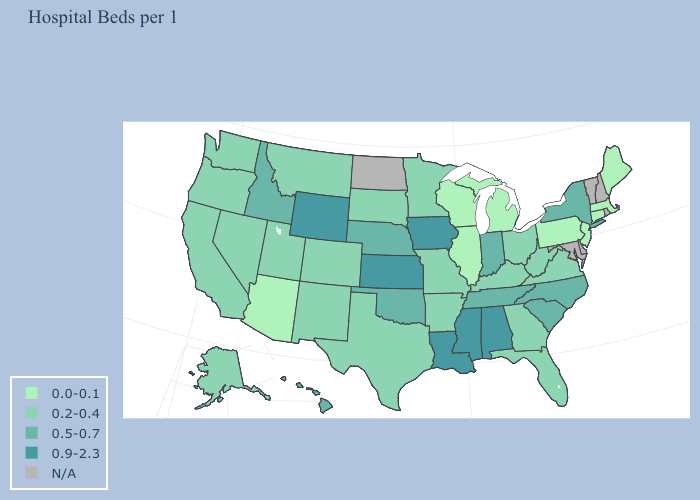How many symbols are there in the legend?
Keep it brief. 5. What is the value of Arkansas?
Short answer required. 0.2-0.4. What is the value of Minnesota?
Quick response, please. 0.2-0.4. What is the value of California?
Quick response, please. 0.2-0.4. What is the highest value in states that border New Hampshire?
Answer briefly. 0.0-0.1. What is the lowest value in the Northeast?
Short answer required. 0.0-0.1. Which states have the lowest value in the West?
Quick response, please. Arizona. Is the legend a continuous bar?
Give a very brief answer. No. Is the legend a continuous bar?
Answer briefly. No. What is the value of Idaho?
Short answer required. 0.5-0.7. Among the states that border Virginia , does North Carolina have the lowest value?
Be succinct. No. Name the states that have a value in the range N/A?
Concise answer only. Delaware, Maryland, New Hampshire, North Dakota, Rhode Island, Vermont. What is the value of Oklahoma?
Be succinct. 0.5-0.7. What is the highest value in the USA?
Be succinct. 0.9-2.3. 